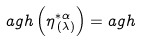<formula> <loc_0><loc_0><loc_500><loc_500>a g h \left ( \eta _ { \, ( \lambda ) } ^ { * \alpha } \right ) = a g h</formula> 